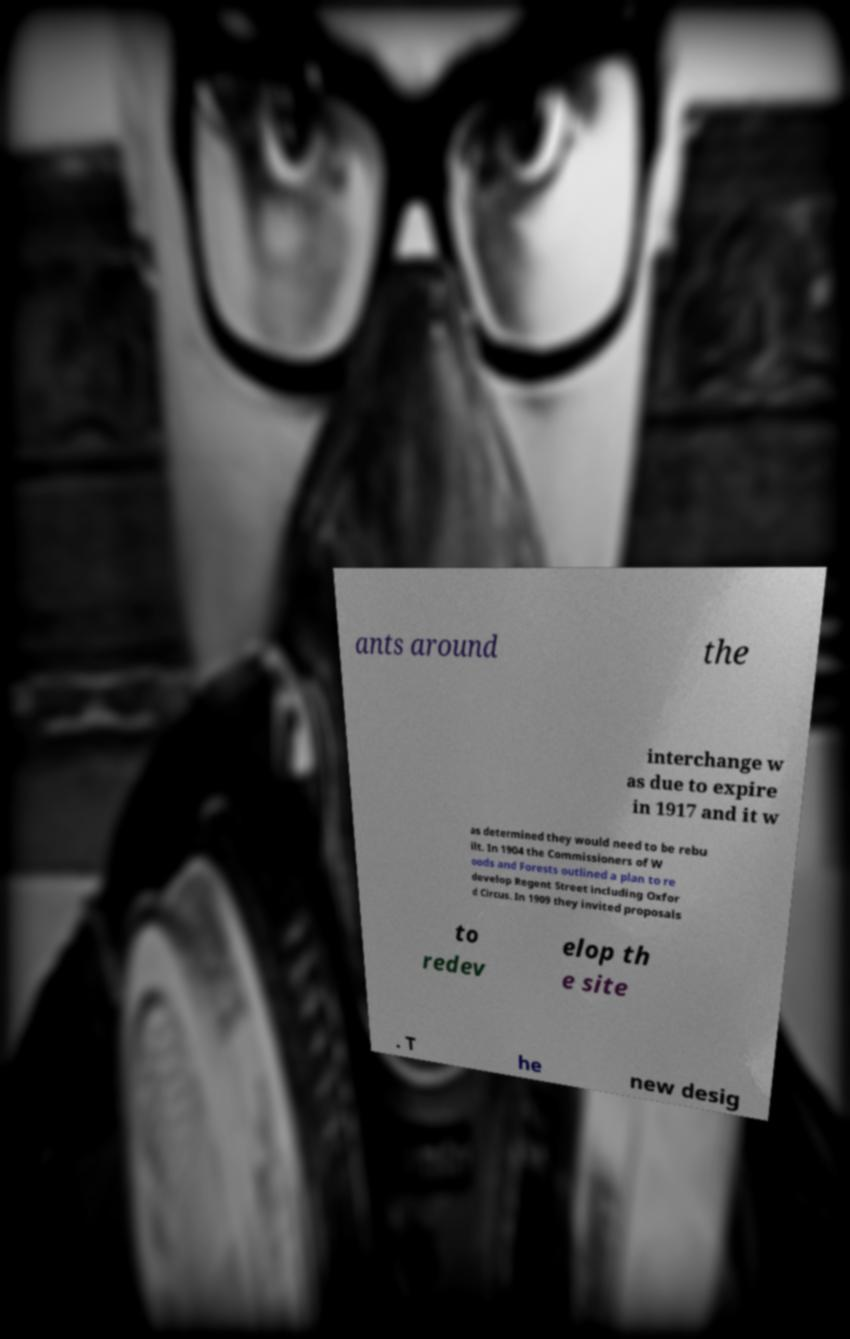Please identify and transcribe the text found in this image. ants around the interchange w as due to expire in 1917 and it w as determined they would need to be rebu ilt. In 1904 the Commissioners of W oods and Forests outlined a plan to re develop Regent Street including Oxfor d Circus. In 1909 they invited proposals to redev elop th e site . T he new desig 